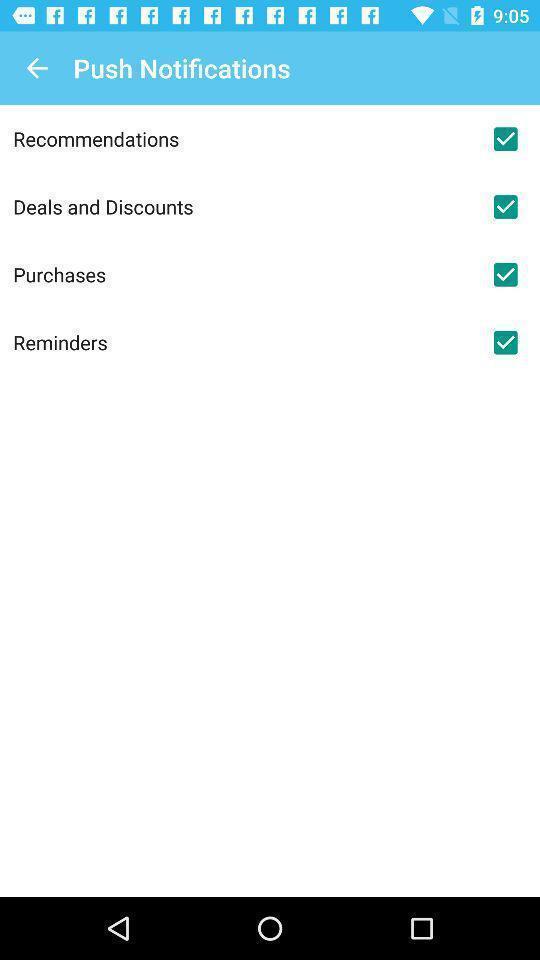Describe the visual elements of this screenshot. Screen displaying the push notifications page. 